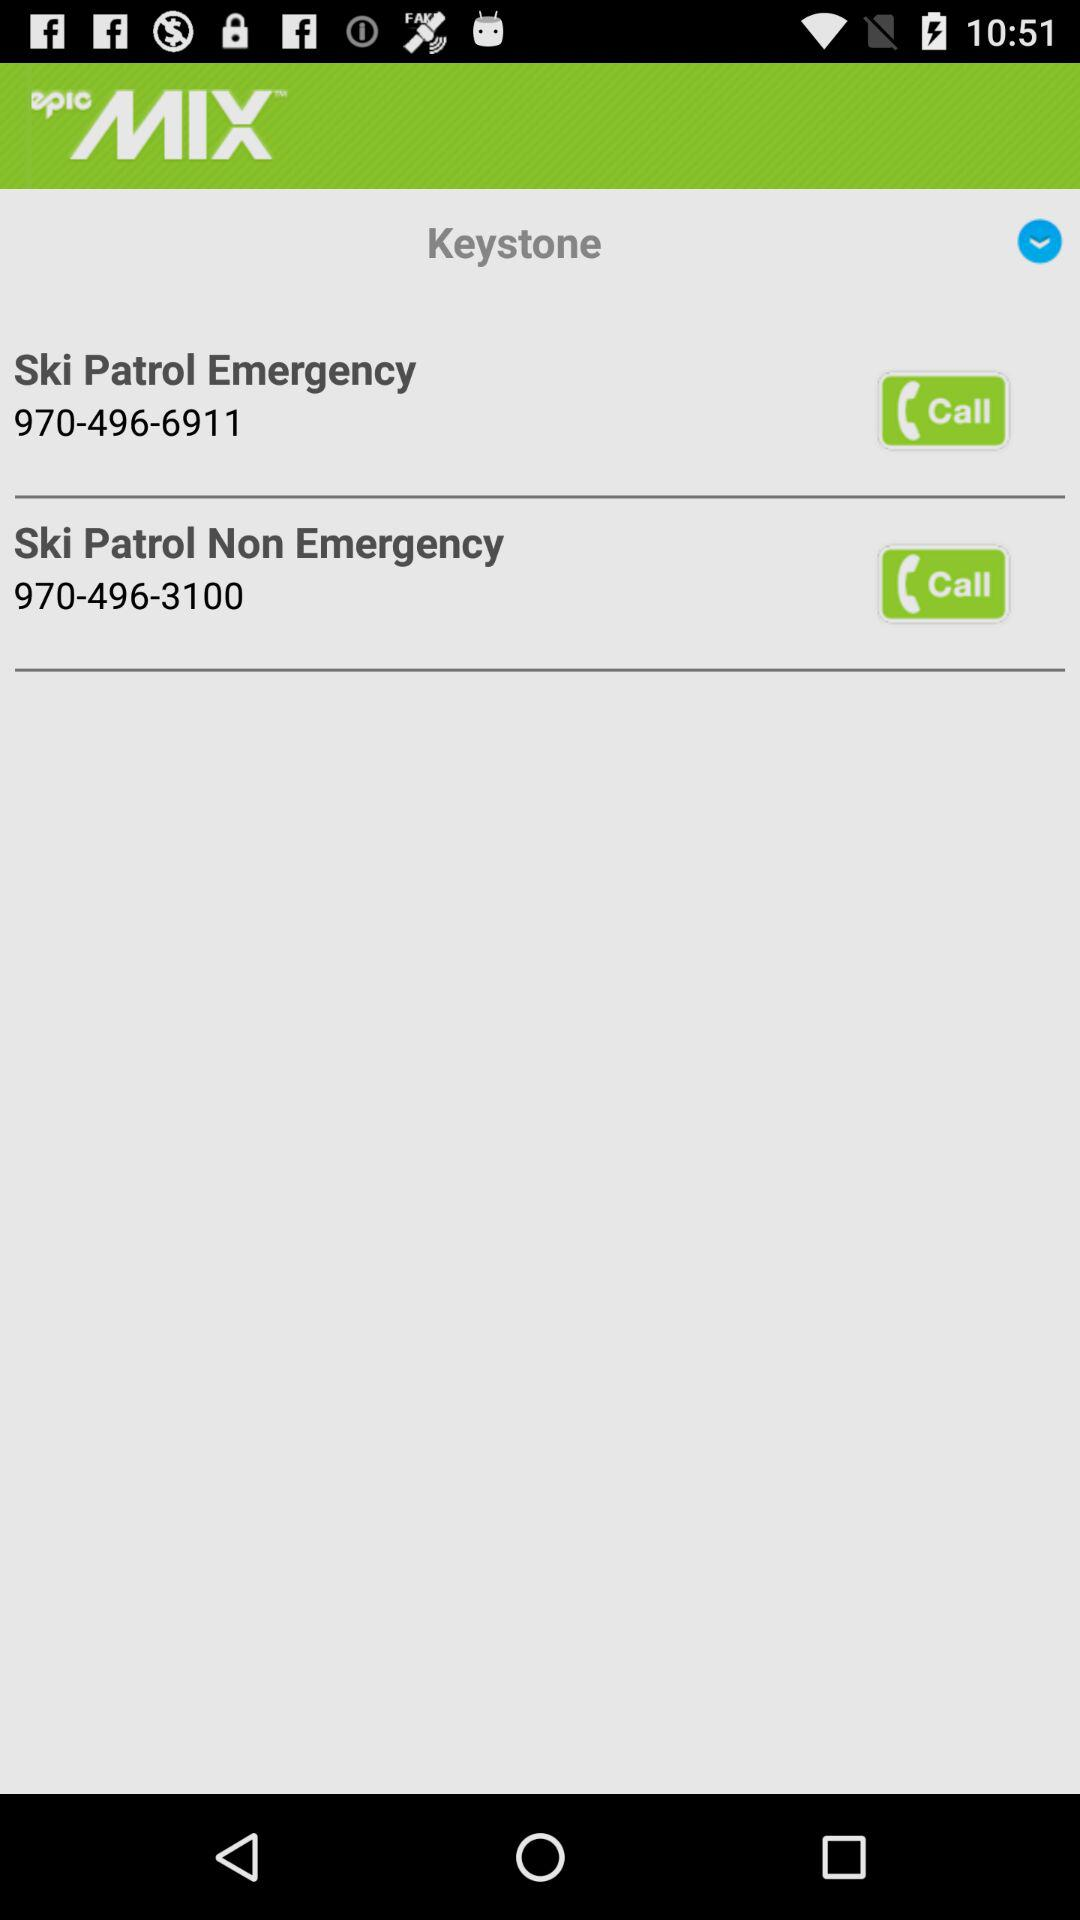What is the emergency contact number for ski patrol? The emergency contact number is 970-496-6911. 